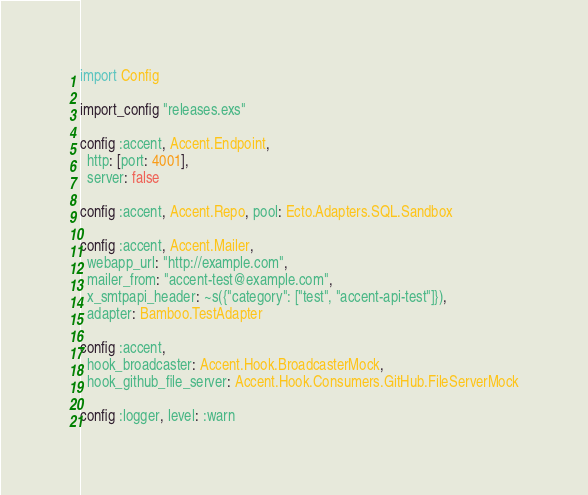<code> <loc_0><loc_0><loc_500><loc_500><_Elixir_>import Config

import_config "releases.exs"

config :accent, Accent.Endpoint,
  http: [port: 4001],
  server: false

config :accent, Accent.Repo, pool: Ecto.Adapters.SQL.Sandbox

config :accent, Accent.Mailer,
  webapp_url: "http://example.com",
  mailer_from: "accent-test@example.com",
  x_smtpapi_header: ~s({"category": ["test", "accent-api-test"]}),
  adapter: Bamboo.TestAdapter

config :accent,
  hook_broadcaster: Accent.Hook.BroadcasterMock,
  hook_github_file_server: Accent.Hook.Consumers.GitHub.FileServerMock

config :logger, level: :warn
</code> 